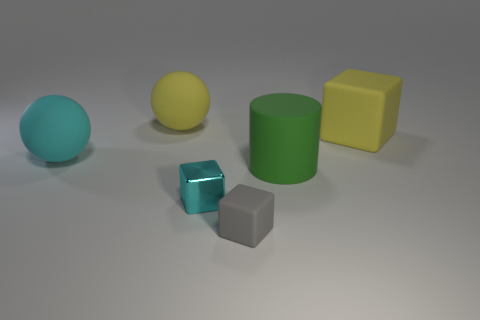Add 1 large blocks. How many objects exist? 7 Subtract all tiny blocks. How many blocks are left? 1 Subtract all balls. How many objects are left? 4 Subtract all cyan balls. How many balls are left? 1 Subtract 1 spheres. How many spheres are left? 1 Subtract all gray cylinders. Subtract all yellow balls. How many cylinders are left? 1 Subtract all red cubes. Subtract all gray matte cubes. How many objects are left? 5 Add 4 large rubber blocks. How many large rubber blocks are left? 5 Add 2 large yellow rubber blocks. How many large yellow rubber blocks exist? 3 Subtract 0 gray cylinders. How many objects are left? 6 